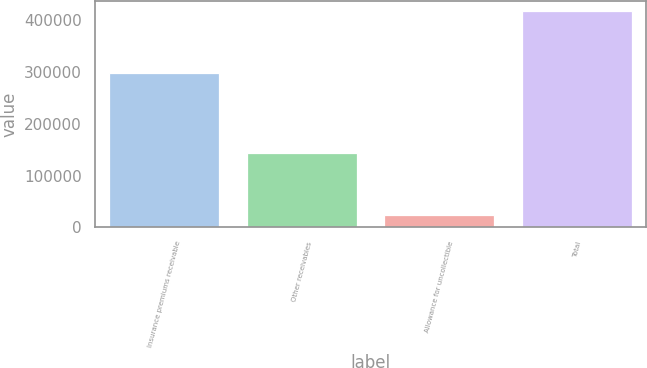Convert chart to OTSL. <chart><loc_0><loc_0><loc_500><loc_500><bar_chart><fcel>Insurance premiums receivable<fcel>Other receivables<fcel>Allowance for uncollectible<fcel>Total<nl><fcel>298271<fcel>143064<fcel>24818<fcel>416517<nl></chart> 